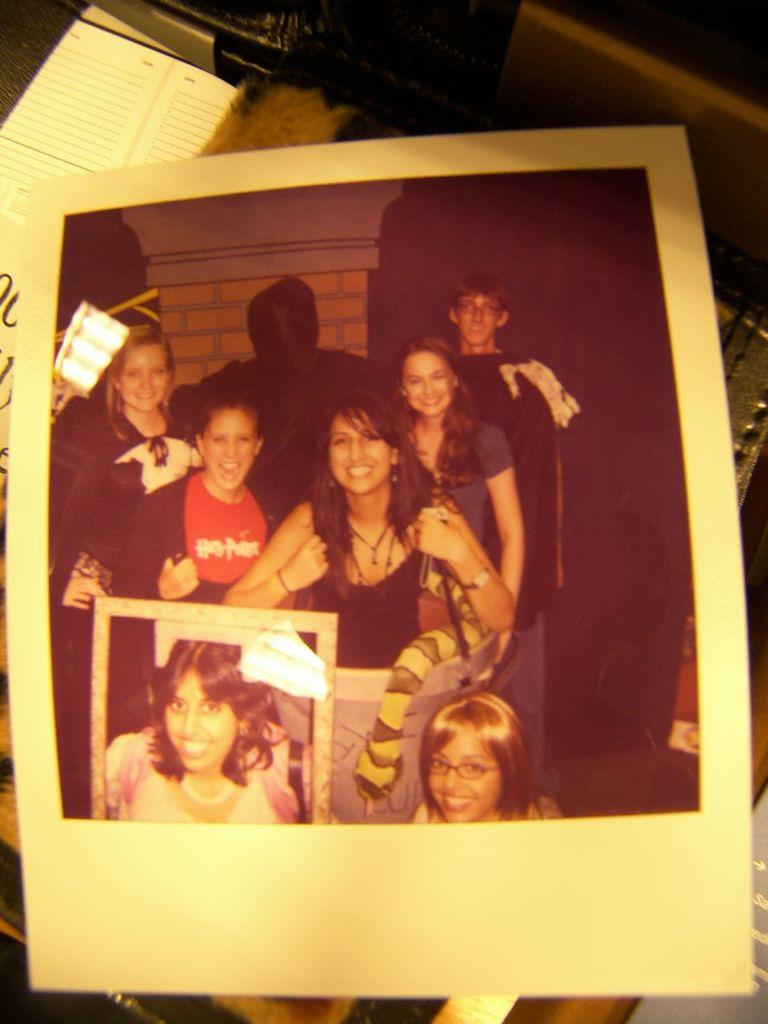What is the main subject of the image? There is a photo in the image. What can be seen in the photo? The photo contains people, and the people in the photo are smiling. Are there any other objects visible in the photo besides the people? Yes, there are other objects visible in the photo. What can be seen in the background of the photo? There are objects in the background of the photo. What color is the map in the image? There is no map present in the image. How many cents are visible in the image? There are no cents visible in the image. 